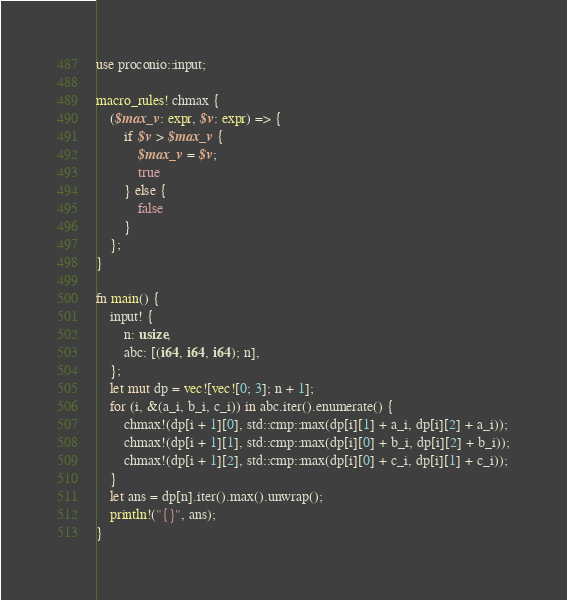<code> <loc_0><loc_0><loc_500><loc_500><_Rust_>use proconio::input;

macro_rules! chmax {
    ($max_v: expr, $v: expr) => {
        if $v > $max_v {
            $max_v = $v;
            true
        } else {
            false
        }
    };
}

fn main() {
    input! {
        n: usize,
        abc: [(i64, i64, i64); n],
    };
    let mut dp = vec![vec![0; 3]; n + 1];
    for (i, &(a_i, b_i, c_i)) in abc.iter().enumerate() {
        chmax!(dp[i + 1][0], std::cmp::max(dp[i][1] + a_i, dp[i][2] + a_i));
        chmax!(dp[i + 1][1], std::cmp::max(dp[i][0] + b_i, dp[i][2] + b_i));
        chmax!(dp[i + 1][2], std::cmp::max(dp[i][0] + c_i, dp[i][1] + c_i));
    }
    let ans = dp[n].iter().max().unwrap();
    println!("{}", ans);
}
</code> 